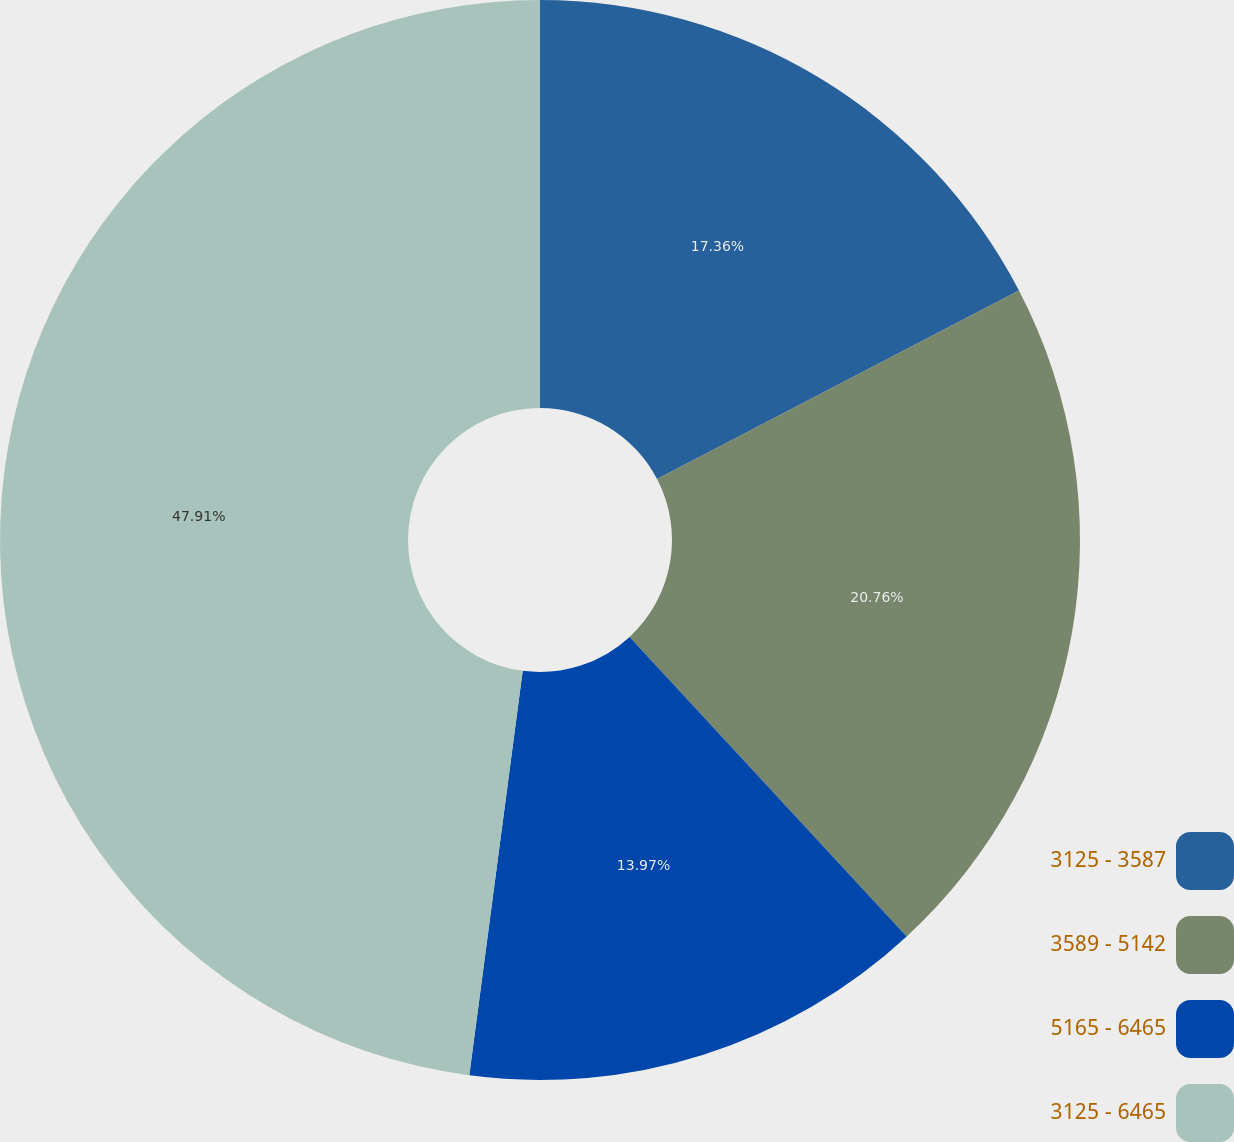Convert chart. <chart><loc_0><loc_0><loc_500><loc_500><pie_chart><fcel>3125 - 3587<fcel>3589 - 5142<fcel>5165 - 6465<fcel>3125 - 6465<nl><fcel>17.36%<fcel>20.76%<fcel>13.97%<fcel>47.91%<nl></chart> 